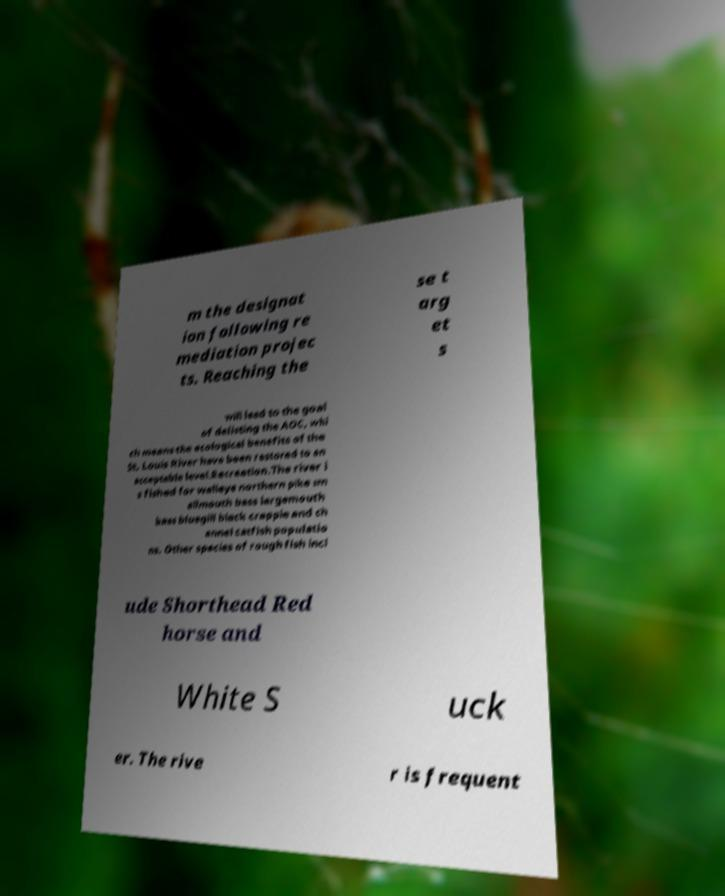Please identify and transcribe the text found in this image. m the designat ion following re mediation projec ts. Reaching the se t arg et s will lead to the goal of delisting the AOC, whi ch means the ecological benefits of the St. Louis River have been restored to an acceptable level.Recreation.The river i s fished for walleye northern pike sm allmouth bass largemouth bass bluegill black crappie and ch annel catfish populatio ns. Other species of rough fish incl ude Shorthead Red horse and White S uck er. The rive r is frequent 